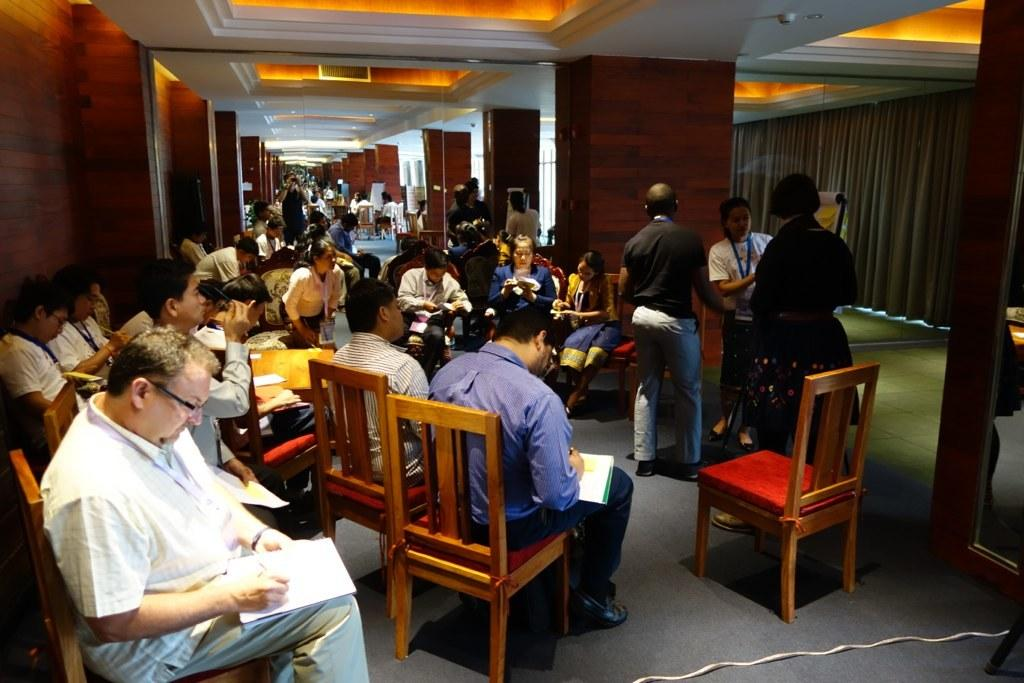How many people are in the image? There is a group of persons in the image. What are the persons doing in the image? The persons are doing some work. What are the persons sitting on while doing their work? The persons are sitting on chairs. How many jail cells can be seen in the image? There is no jail or jail cells present in the image. What is the rate of productivity for the persons in the image? There is no information about the rate of productivity for the persons in the image. 